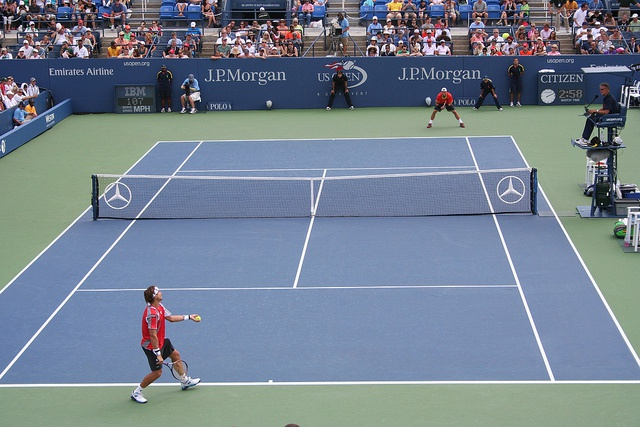Describe the objects in this image and their specific colors. I can see people in darkgray, black, gray, navy, and brown tones, people in darkgray, black, brown, and maroon tones, people in darkgray, black, navy, maroon, and gray tones, people in darkgray, black, navy, gray, and maroon tones, and people in darkgray, black, gray, lightgray, and navy tones in this image. 